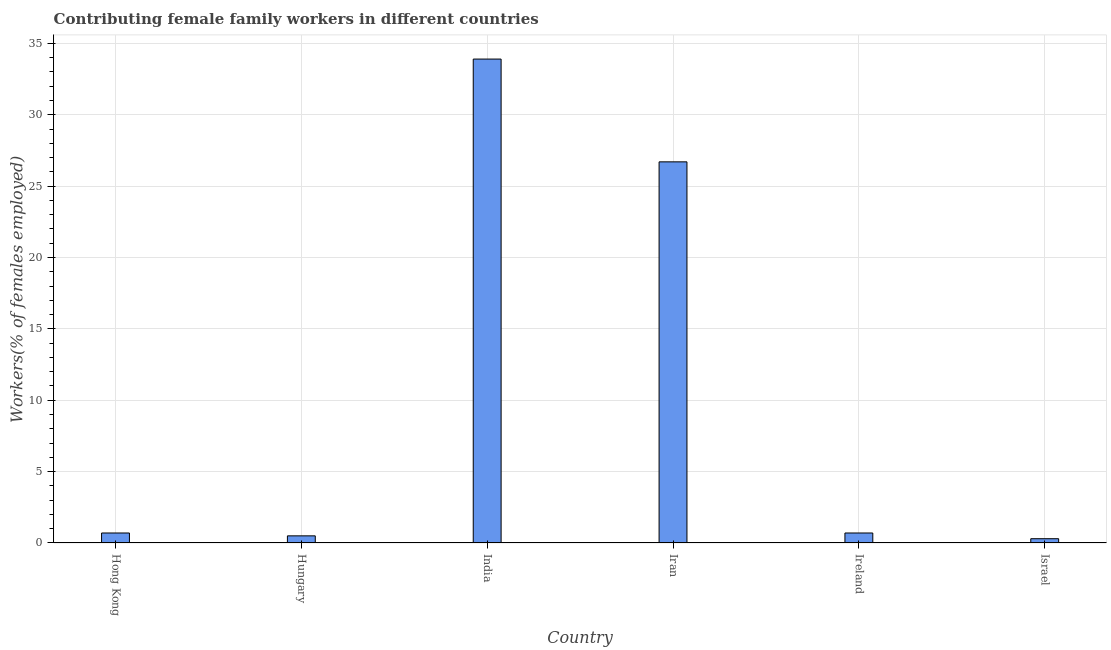Does the graph contain grids?
Make the answer very short. Yes. What is the title of the graph?
Offer a very short reply. Contributing female family workers in different countries. What is the label or title of the X-axis?
Keep it short and to the point. Country. What is the label or title of the Y-axis?
Provide a succinct answer. Workers(% of females employed). What is the contributing female family workers in Israel?
Your answer should be compact. 0.3. Across all countries, what is the maximum contributing female family workers?
Offer a very short reply. 33.9. Across all countries, what is the minimum contributing female family workers?
Give a very brief answer. 0.3. In which country was the contributing female family workers maximum?
Make the answer very short. India. In which country was the contributing female family workers minimum?
Offer a terse response. Israel. What is the sum of the contributing female family workers?
Offer a very short reply. 62.8. What is the difference between the contributing female family workers in Hungary and Ireland?
Your response must be concise. -0.2. What is the average contributing female family workers per country?
Provide a short and direct response. 10.47. What is the median contributing female family workers?
Provide a succinct answer. 0.7. In how many countries, is the contributing female family workers greater than 16 %?
Provide a short and direct response. 2. What is the ratio of the contributing female family workers in Ireland to that in Israel?
Your response must be concise. 2.33. Is the contributing female family workers in India less than that in Israel?
Provide a short and direct response. No. Is the difference between the contributing female family workers in India and Iran greater than the difference between any two countries?
Provide a succinct answer. No. What is the difference between the highest and the second highest contributing female family workers?
Your answer should be very brief. 7.2. What is the difference between the highest and the lowest contributing female family workers?
Provide a succinct answer. 33.6. How many bars are there?
Your answer should be very brief. 6. Are all the bars in the graph horizontal?
Provide a short and direct response. No. How many countries are there in the graph?
Your answer should be very brief. 6. What is the difference between two consecutive major ticks on the Y-axis?
Make the answer very short. 5. What is the Workers(% of females employed) of Hong Kong?
Give a very brief answer. 0.7. What is the Workers(% of females employed) in India?
Your answer should be compact. 33.9. What is the Workers(% of females employed) in Iran?
Offer a very short reply. 26.7. What is the Workers(% of females employed) in Ireland?
Provide a succinct answer. 0.7. What is the Workers(% of females employed) in Israel?
Make the answer very short. 0.3. What is the difference between the Workers(% of females employed) in Hong Kong and Hungary?
Provide a short and direct response. 0.2. What is the difference between the Workers(% of females employed) in Hong Kong and India?
Keep it short and to the point. -33.2. What is the difference between the Workers(% of females employed) in Hungary and India?
Provide a short and direct response. -33.4. What is the difference between the Workers(% of females employed) in Hungary and Iran?
Offer a terse response. -26.2. What is the difference between the Workers(% of females employed) in Hungary and Israel?
Make the answer very short. 0.2. What is the difference between the Workers(% of females employed) in India and Iran?
Keep it short and to the point. 7.2. What is the difference between the Workers(% of females employed) in India and Ireland?
Provide a succinct answer. 33.2. What is the difference between the Workers(% of females employed) in India and Israel?
Give a very brief answer. 33.6. What is the difference between the Workers(% of females employed) in Iran and Israel?
Ensure brevity in your answer.  26.4. What is the difference between the Workers(% of females employed) in Ireland and Israel?
Provide a short and direct response. 0.4. What is the ratio of the Workers(% of females employed) in Hong Kong to that in India?
Your answer should be compact. 0.02. What is the ratio of the Workers(% of females employed) in Hong Kong to that in Iran?
Provide a short and direct response. 0.03. What is the ratio of the Workers(% of females employed) in Hong Kong to that in Israel?
Your answer should be compact. 2.33. What is the ratio of the Workers(% of females employed) in Hungary to that in India?
Your response must be concise. 0.01. What is the ratio of the Workers(% of females employed) in Hungary to that in Iran?
Your answer should be very brief. 0.02. What is the ratio of the Workers(% of females employed) in Hungary to that in Ireland?
Provide a short and direct response. 0.71. What is the ratio of the Workers(% of females employed) in Hungary to that in Israel?
Your answer should be very brief. 1.67. What is the ratio of the Workers(% of females employed) in India to that in Iran?
Give a very brief answer. 1.27. What is the ratio of the Workers(% of females employed) in India to that in Ireland?
Your response must be concise. 48.43. What is the ratio of the Workers(% of females employed) in India to that in Israel?
Offer a terse response. 113. What is the ratio of the Workers(% of females employed) in Iran to that in Ireland?
Your answer should be compact. 38.14. What is the ratio of the Workers(% of females employed) in Iran to that in Israel?
Make the answer very short. 89. What is the ratio of the Workers(% of females employed) in Ireland to that in Israel?
Ensure brevity in your answer.  2.33. 